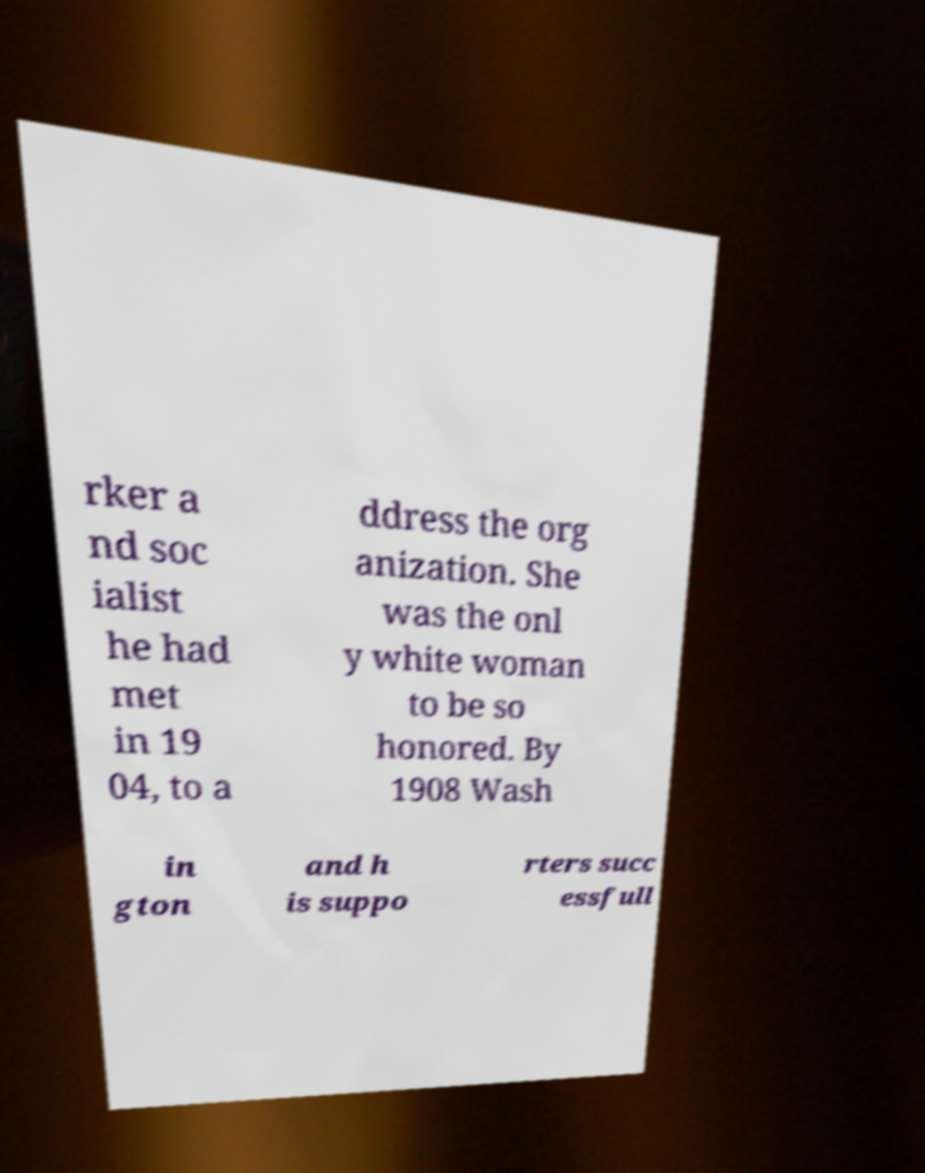For documentation purposes, I need the text within this image transcribed. Could you provide that? rker a nd soc ialist he had met in 19 04, to a ddress the org anization. She was the onl y white woman to be so honored. By 1908 Wash in gton and h is suppo rters succ essfull 